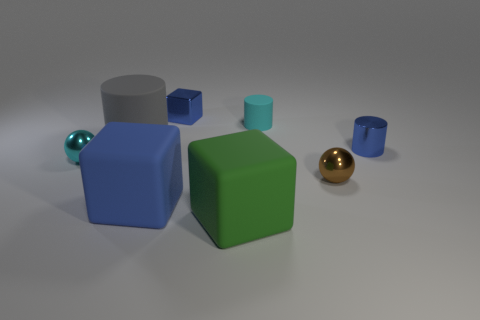What number of other things are there of the same shape as the big green rubber object?
Give a very brief answer. 2. Does the cyan matte cylinder have the same size as the gray cylinder?
Your response must be concise. No. Is there a large blue matte cylinder?
Make the answer very short. No. Is there any other thing that is made of the same material as the big blue object?
Provide a short and direct response. Yes. Is there another cylinder that has the same material as the large gray cylinder?
Offer a very short reply. Yes. There is a cyan cylinder that is the same size as the cyan metallic object; what material is it?
Keep it short and to the point. Rubber. What number of big objects are the same shape as the small matte object?
Provide a succinct answer. 1. The other cylinder that is the same material as the cyan cylinder is what size?
Offer a terse response. Large. What material is the small thing that is both behind the big gray matte thing and to the left of the big green object?
Provide a short and direct response. Metal. What number of green blocks have the same size as the blue matte thing?
Your answer should be compact. 1. 